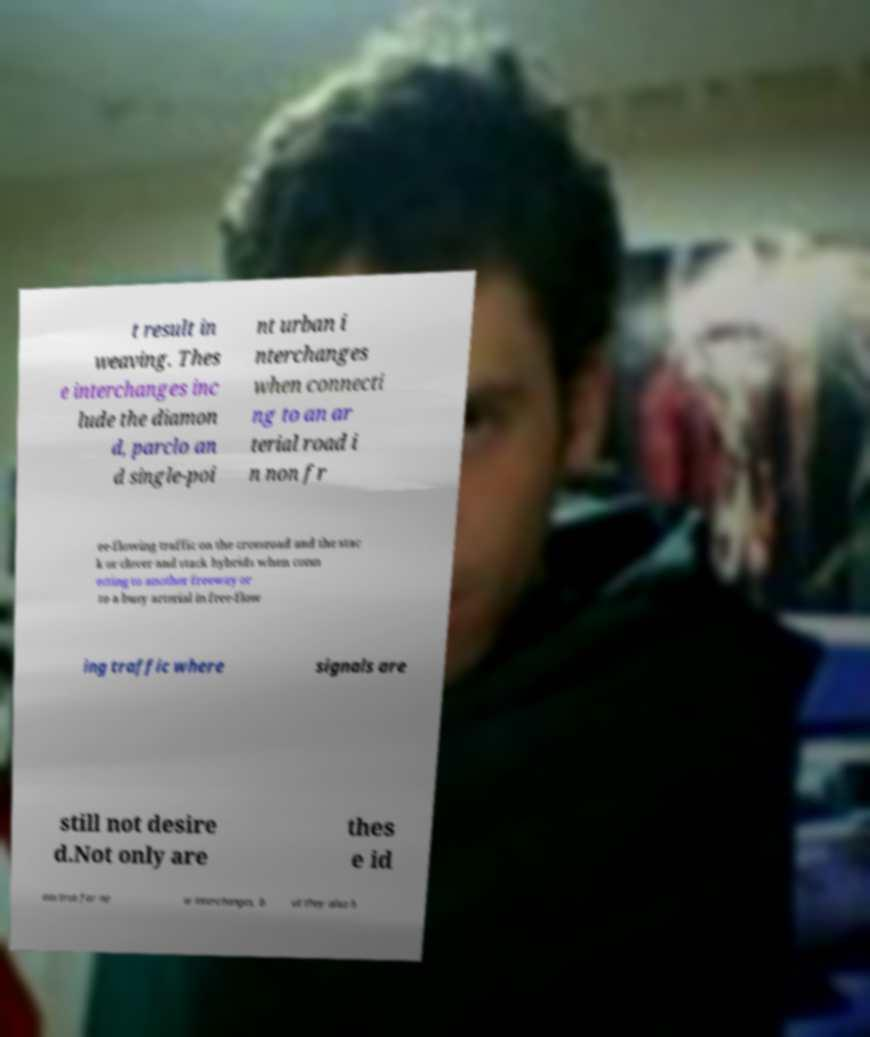Could you extract and type out the text from this image? t result in weaving. Thes e interchanges inc lude the diamon d, parclo an d single-poi nt urban i nterchanges when connecti ng to an ar terial road i n non fr ee-flowing traffic on the crossroad and the stac k or clover and stack hybrids when conn ecting to another freeway or to a busy arterial in free-flow ing traffic where signals are still not desire d.Not only are thes e id eas true for ne w interchanges, b ut they also h 